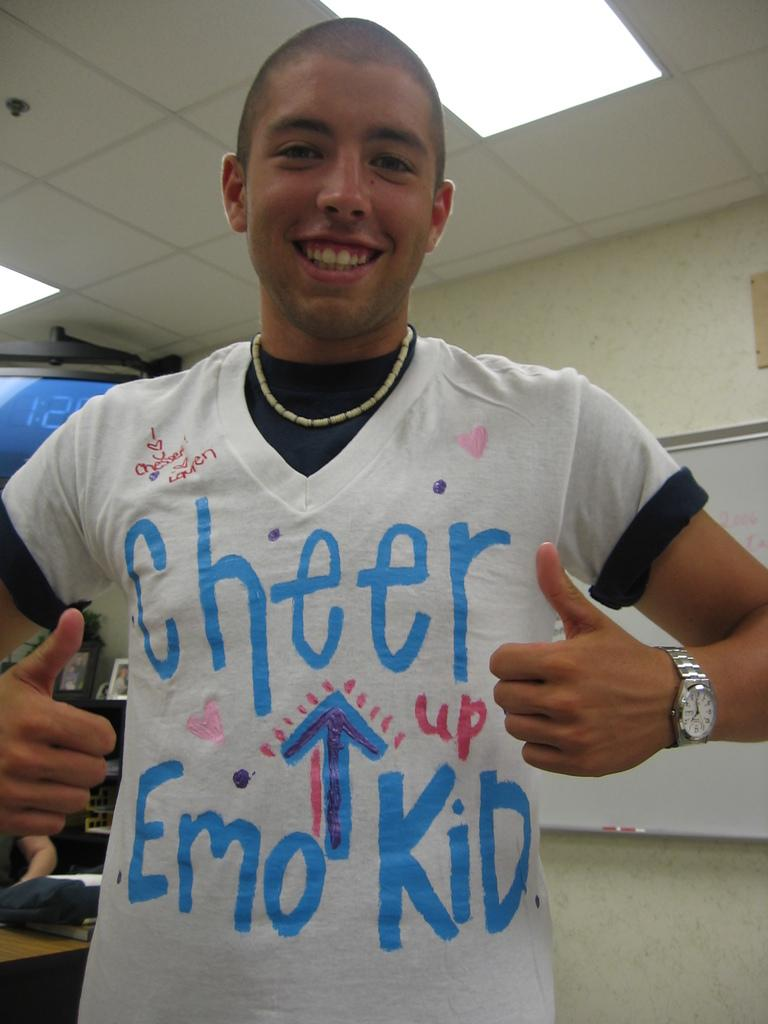<image>
Render a clear and concise summary of the photo. A smiling person has a t-shirt that says cheer up on it. 